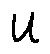<formula> <loc_0><loc_0><loc_500><loc_500>u</formula> 